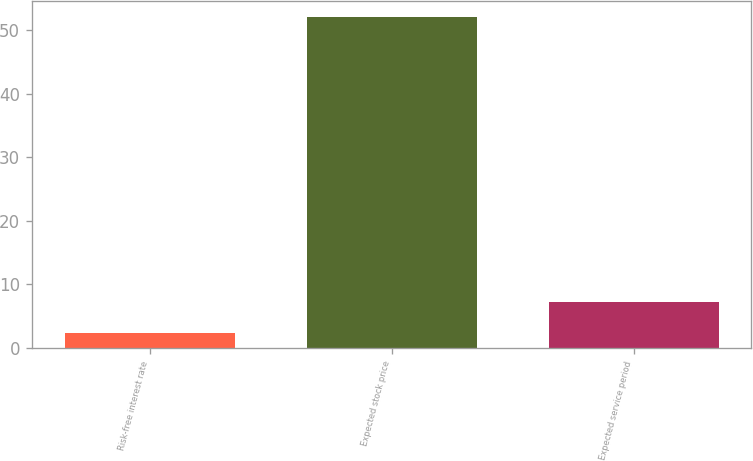Convert chart to OTSL. <chart><loc_0><loc_0><loc_500><loc_500><bar_chart><fcel>Risk-free interest rate<fcel>Expected stock price<fcel>Expected service period<nl><fcel>2.3<fcel>52.1<fcel>7.28<nl></chart> 